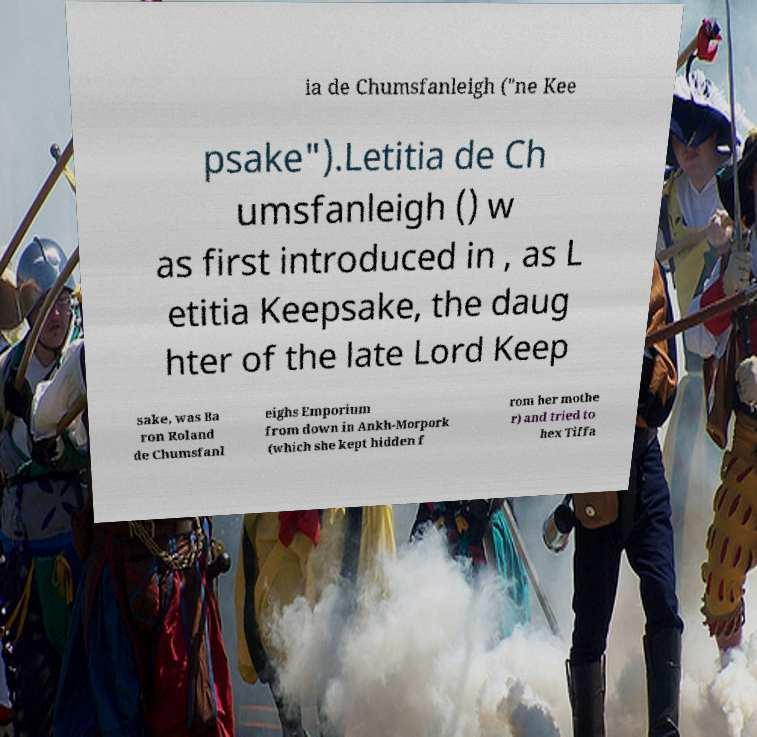I need the written content from this picture converted into text. Can you do that? ia de Chumsfanleigh ("ne Kee psake").Letitia de Ch umsfanleigh () w as first introduced in , as L etitia Keepsake, the daug hter of the late Lord Keep sake, was Ba ron Roland de Chumsfanl eighs Emporium from down in Ankh-Morpork (which she kept hidden f rom her mothe r) and tried to hex Tiffa 